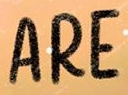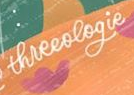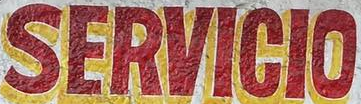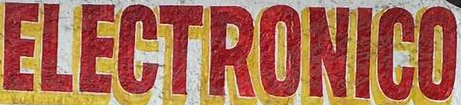Read the text content from these images in order, separated by a semicolon. ARE; threeologie; SERVICIO; ELECTRONICO 